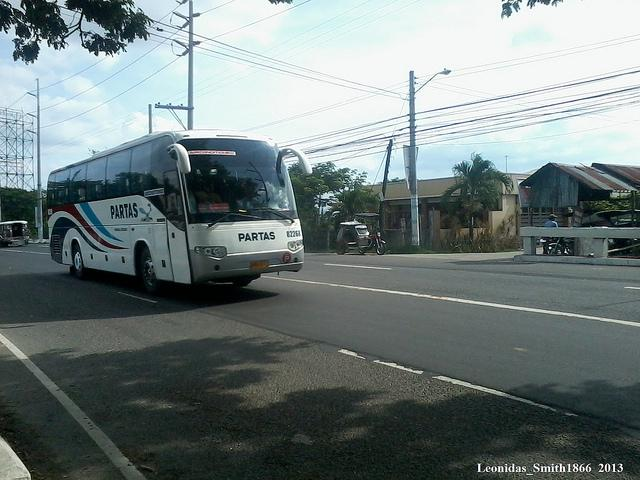What type of lines are located above the street?

Choices:
A) cell
B) power
C) water
D) sewage power 